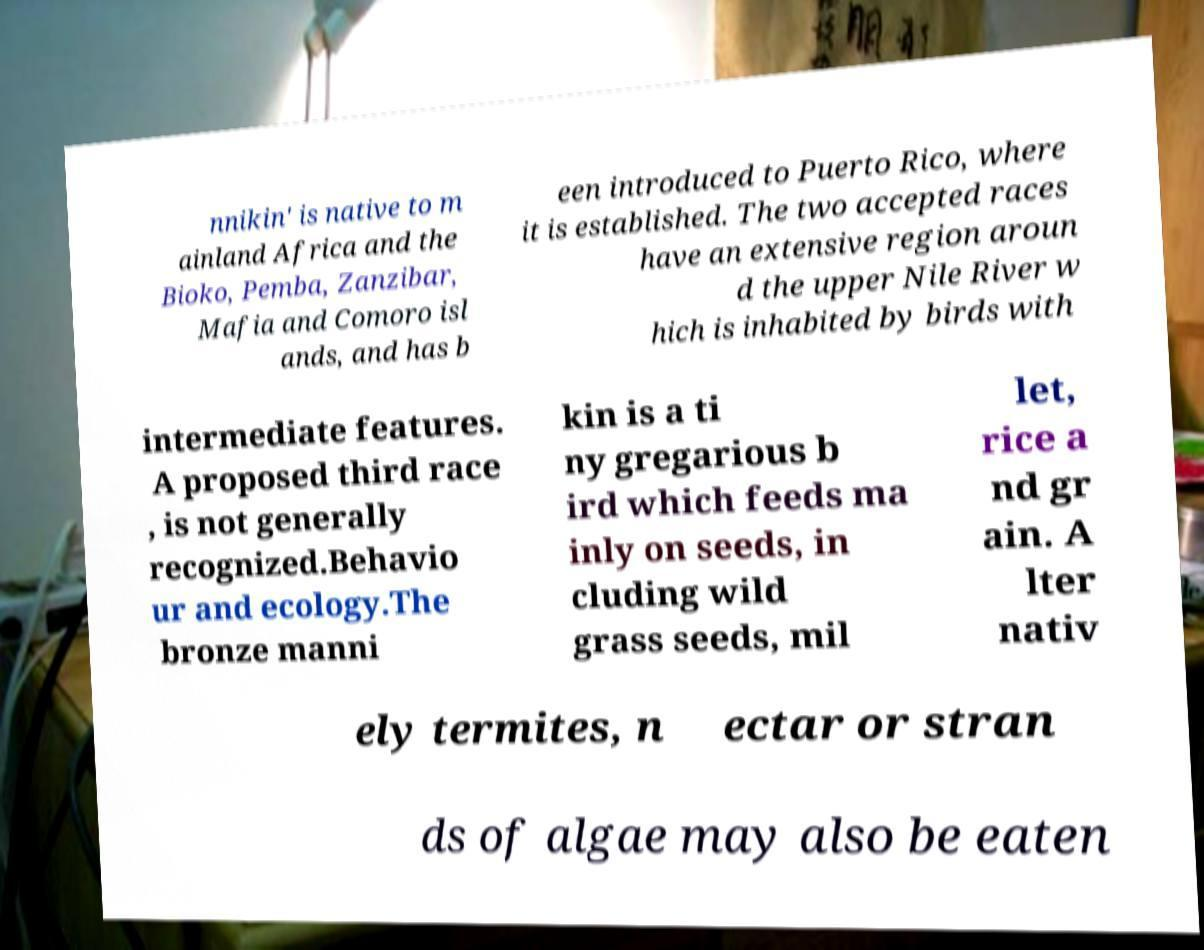Can you read and provide the text displayed in the image?This photo seems to have some interesting text. Can you extract and type it out for me? nnikin' is native to m ainland Africa and the Bioko, Pemba, Zanzibar, Mafia and Comoro isl ands, and has b een introduced to Puerto Rico, where it is established. The two accepted races have an extensive region aroun d the upper Nile River w hich is inhabited by birds with intermediate features. A proposed third race , is not generally recognized.Behavio ur and ecology.The bronze manni kin is a ti ny gregarious b ird which feeds ma inly on seeds, in cluding wild grass seeds, mil let, rice a nd gr ain. A lter nativ ely termites, n ectar or stran ds of algae may also be eaten 